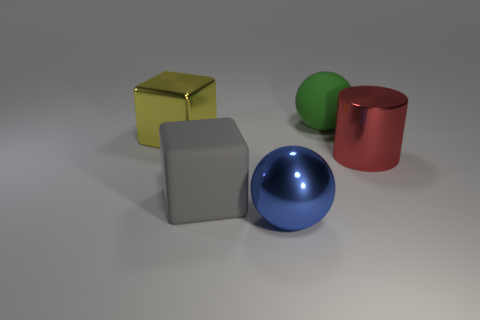Is there any other thing that is made of the same material as the green object?
Your response must be concise. Yes. Is the large green ball made of the same material as the red cylinder right of the large gray object?
Your answer should be compact. No. There is a matte object in front of the big ball right of the blue thing; what is its shape?
Keep it short and to the point. Cube. What number of large things are either purple rubber cubes or yellow blocks?
Make the answer very short. 1. How many big green objects have the same shape as the large gray matte thing?
Offer a very short reply. 0. Do the red object and the matte object that is left of the large green sphere have the same shape?
Your answer should be compact. No. There is a yellow block; what number of big red cylinders are behind it?
Your response must be concise. 0. Is there a green rubber object of the same size as the gray cube?
Provide a short and direct response. Yes. Do the big object behind the yellow shiny cube and the big gray object have the same shape?
Your answer should be compact. No. The metal cylinder is what color?
Your answer should be compact. Red. 